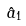<formula> <loc_0><loc_0><loc_500><loc_500>\hat { a } _ { 1 }</formula> 